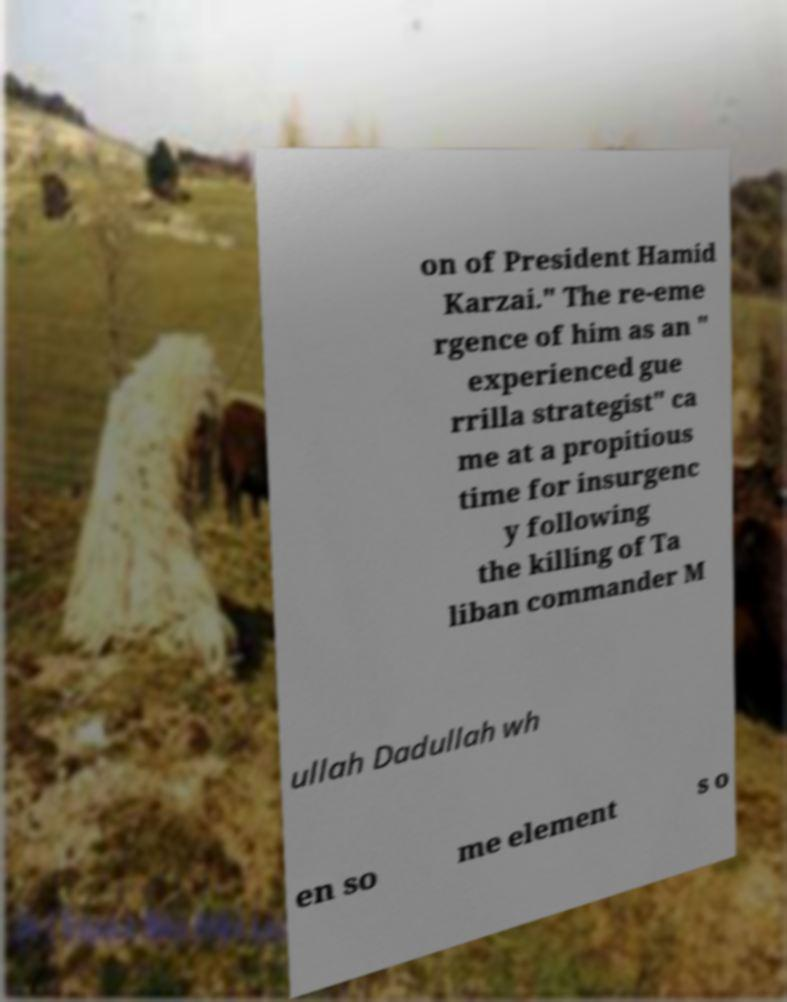Can you read and provide the text displayed in the image?This photo seems to have some interesting text. Can you extract and type it out for me? on of President Hamid Karzai." The re-eme rgence of him as an " experienced gue rrilla strategist" ca me at a propitious time for insurgenc y following the killing of Ta liban commander M ullah Dadullah wh en so me element s o 